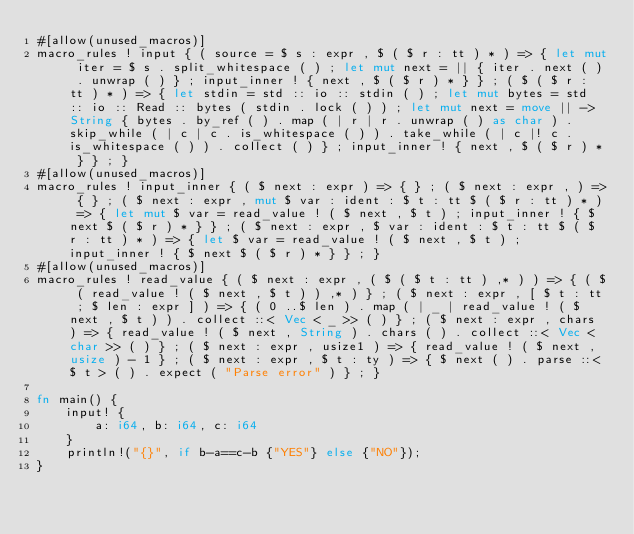Convert code to text. <code><loc_0><loc_0><loc_500><loc_500><_Rust_>#[allow(unused_macros)]
macro_rules ! input { ( source = $ s : expr , $ ( $ r : tt ) * ) => { let mut iter = $ s . split_whitespace ( ) ; let mut next = || { iter . next ( ) . unwrap ( ) } ; input_inner ! { next , $ ( $ r ) * } } ; ( $ ( $ r : tt ) * ) => { let stdin = std :: io :: stdin ( ) ; let mut bytes = std :: io :: Read :: bytes ( stdin . lock ( ) ) ; let mut next = move || -> String { bytes . by_ref ( ) . map ( | r | r . unwrap ( ) as char ) . skip_while ( | c | c . is_whitespace ( ) ) . take_while ( | c |! c . is_whitespace ( ) ) . collect ( ) } ; input_inner ! { next , $ ( $ r ) * } } ; }
#[allow(unused_macros)]
macro_rules ! input_inner { ( $ next : expr ) => { } ; ( $ next : expr , ) => { } ; ( $ next : expr , mut $ var : ident : $ t : tt $ ( $ r : tt ) * ) => { let mut $ var = read_value ! ( $ next , $ t ) ; input_inner ! { $ next $ ( $ r ) * } } ; ( $ next : expr , $ var : ident : $ t : tt $ ( $ r : tt ) * ) => { let $ var = read_value ! ( $ next , $ t ) ; input_inner ! { $ next $ ( $ r ) * } } ; }
#[allow(unused_macros)]
macro_rules ! read_value { ( $ next : expr , ( $ ( $ t : tt ) ,* ) ) => { ( $ ( read_value ! ( $ next , $ t ) ) ,* ) } ; ( $ next : expr , [ $ t : tt ; $ len : expr ] ) => { ( 0 ..$ len ) . map ( | _ | read_value ! ( $ next , $ t ) ) . collect ::< Vec < _ >> ( ) } ; ( $ next : expr , chars ) => { read_value ! ( $ next , String ) . chars ( ) . collect ::< Vec < char >> ( ) } ; ( $ next : expr , usize1 ) => { read_value ! ( $ next , usize ) - 1 } ; ( $ next : expr , $ t : ty ) => { $ next ( ) . parse ::<$ t > ( ) . expect ( "Parse error" ) } ; }

fn main() {
    input! {
        a: i64, b: i64, c: i64
    }
    println!("{}", if b-a==c-b {"YES"} else {"NO"});
}</code> 